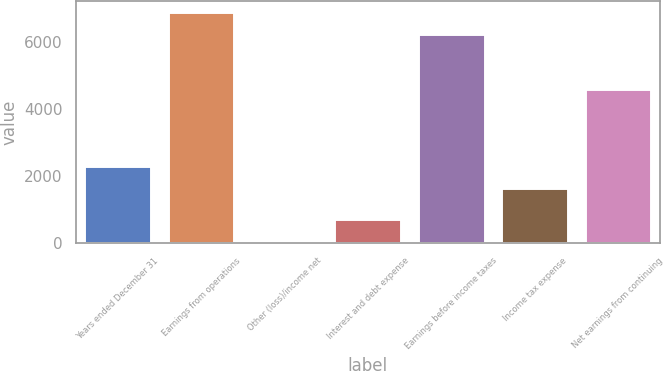Convert chart to OTSL. <chart><loc_0><loc_0><loc_500><loc_500><bar_chart><fcel>Years ended December 31<fcel>Earnings from operations<fcel>Other (loss)/income net<fcel>Interest and debt expense<fcel>Earnings before income taxes<fcel>Income tax expense<fcel>Net earnings from continuing<nl><fcel>2296.6<fcel>6882.6<fcel>56<fcel>706.6<fcel>6232<fcel>1646<fcel>4586<nl></chart> 